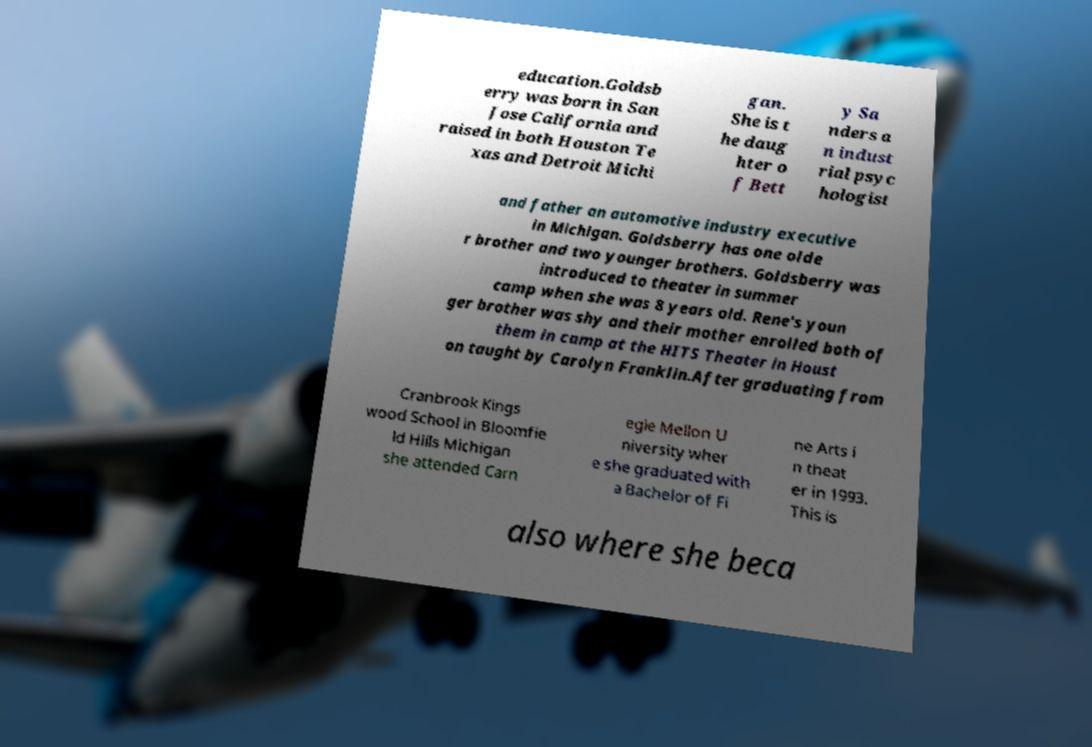Can you accurately transcribe the text from the provided image for me? education.Goldsb erry was born in San Jose California and raised in both Houston Te xas and Detroit Michi gan. She is t he daug hter o f Bett y Sa nders a n indust rial psyc hologist and father an automotive industry executive in Michigan. Goldsberry has one olde r brother and two younger brothers. Goldsberry was introduced to theater in summer camp when she was 8 years old. Rene's youn ger brother was shy and their mother enrolled both of them in camp at the HITS Theater in Houst on taught by Carolyn Franklin.After graduating from Cranbrook Kings wood School in Bloomfie ld Hills Michigan she attended Carn egie Mellon U niversity wher e she graduated with a Bachelor of Fi ne Arts i n theat er in 1993. This is also where she beca 